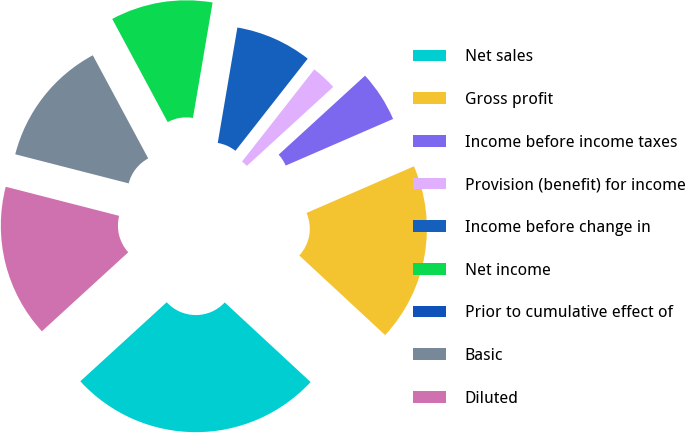Convert chart to OTSL. <chart><loc_0><loc_0><loc_500><loc_500><pie_chart><fcel>Net sales<fcel>Gross profit<fcel>Income before income taxes<fcel>Provision (benefit) for income<fcel>Income before change in<fcel>Net income<fcel>Prior to cumulative effect of<fcel>Basic<fcel>Diluted<nl><fcel>26.31%<fcel>18.42%<fcel>5.27%<fcel>2.63%<fcel>7.9%<fcel>10.53%<fcel>0.0%<fcel>13.16%<fcel>15.79%<nl></chart> 